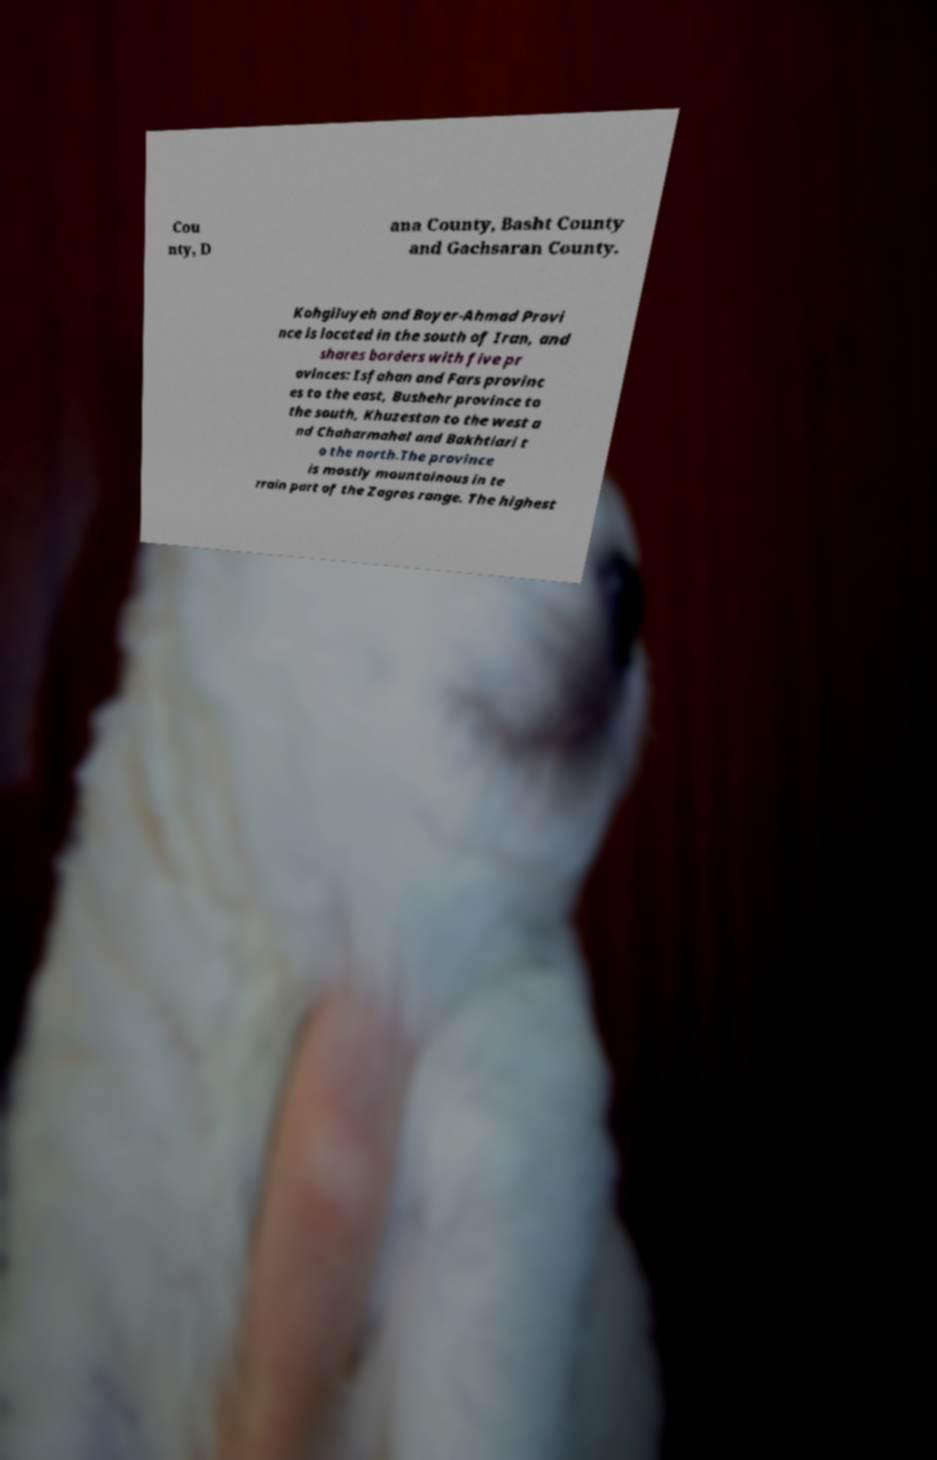Please identify and transcribe the text found in this image. Cou nty, D ana County, Basht County and Gachsaran County. Kohgiluyeh and Boyer-Ahmad Provi nce is located in the south of Iran, and shares borders with five pr ovinces: Isfahan and Fars provinc es to the east, Bushehr province to the south, Khuzestan to the west a nd Chaharmahal and Bakhtiari t o the north.The province is mostly mountainous in te rrain part of the Zagros range. The highest 